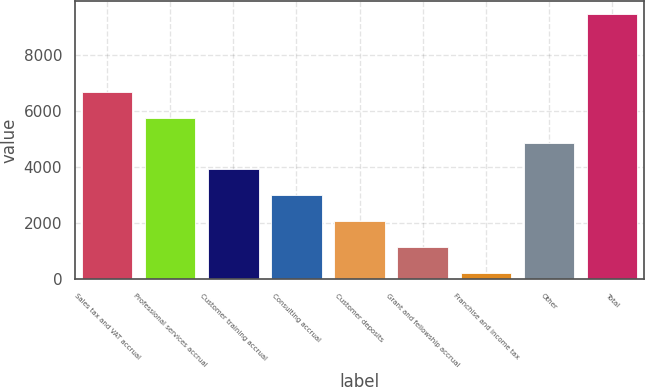<chart> <loc_0><loc_0><loc_500><loc_500><bar_chart><fcel>Sales tax and VAT accrual<fcel>Professional services accrual<fcel>Customer training accrual<fcel>Consulting accrual<fcel>Customer deposits<fcel>Grant and fellowship accrual<fcel>Franchise and income tax<fcel>Other<fcel>Total<nl><fcel>6675.2<fcel>5755.6<fcel>3916.4<fcel>2996.8<fcel>2077.2<fcel>1157.6<fcel>238<fcel>4836<fcel>9434<nl></chart> 